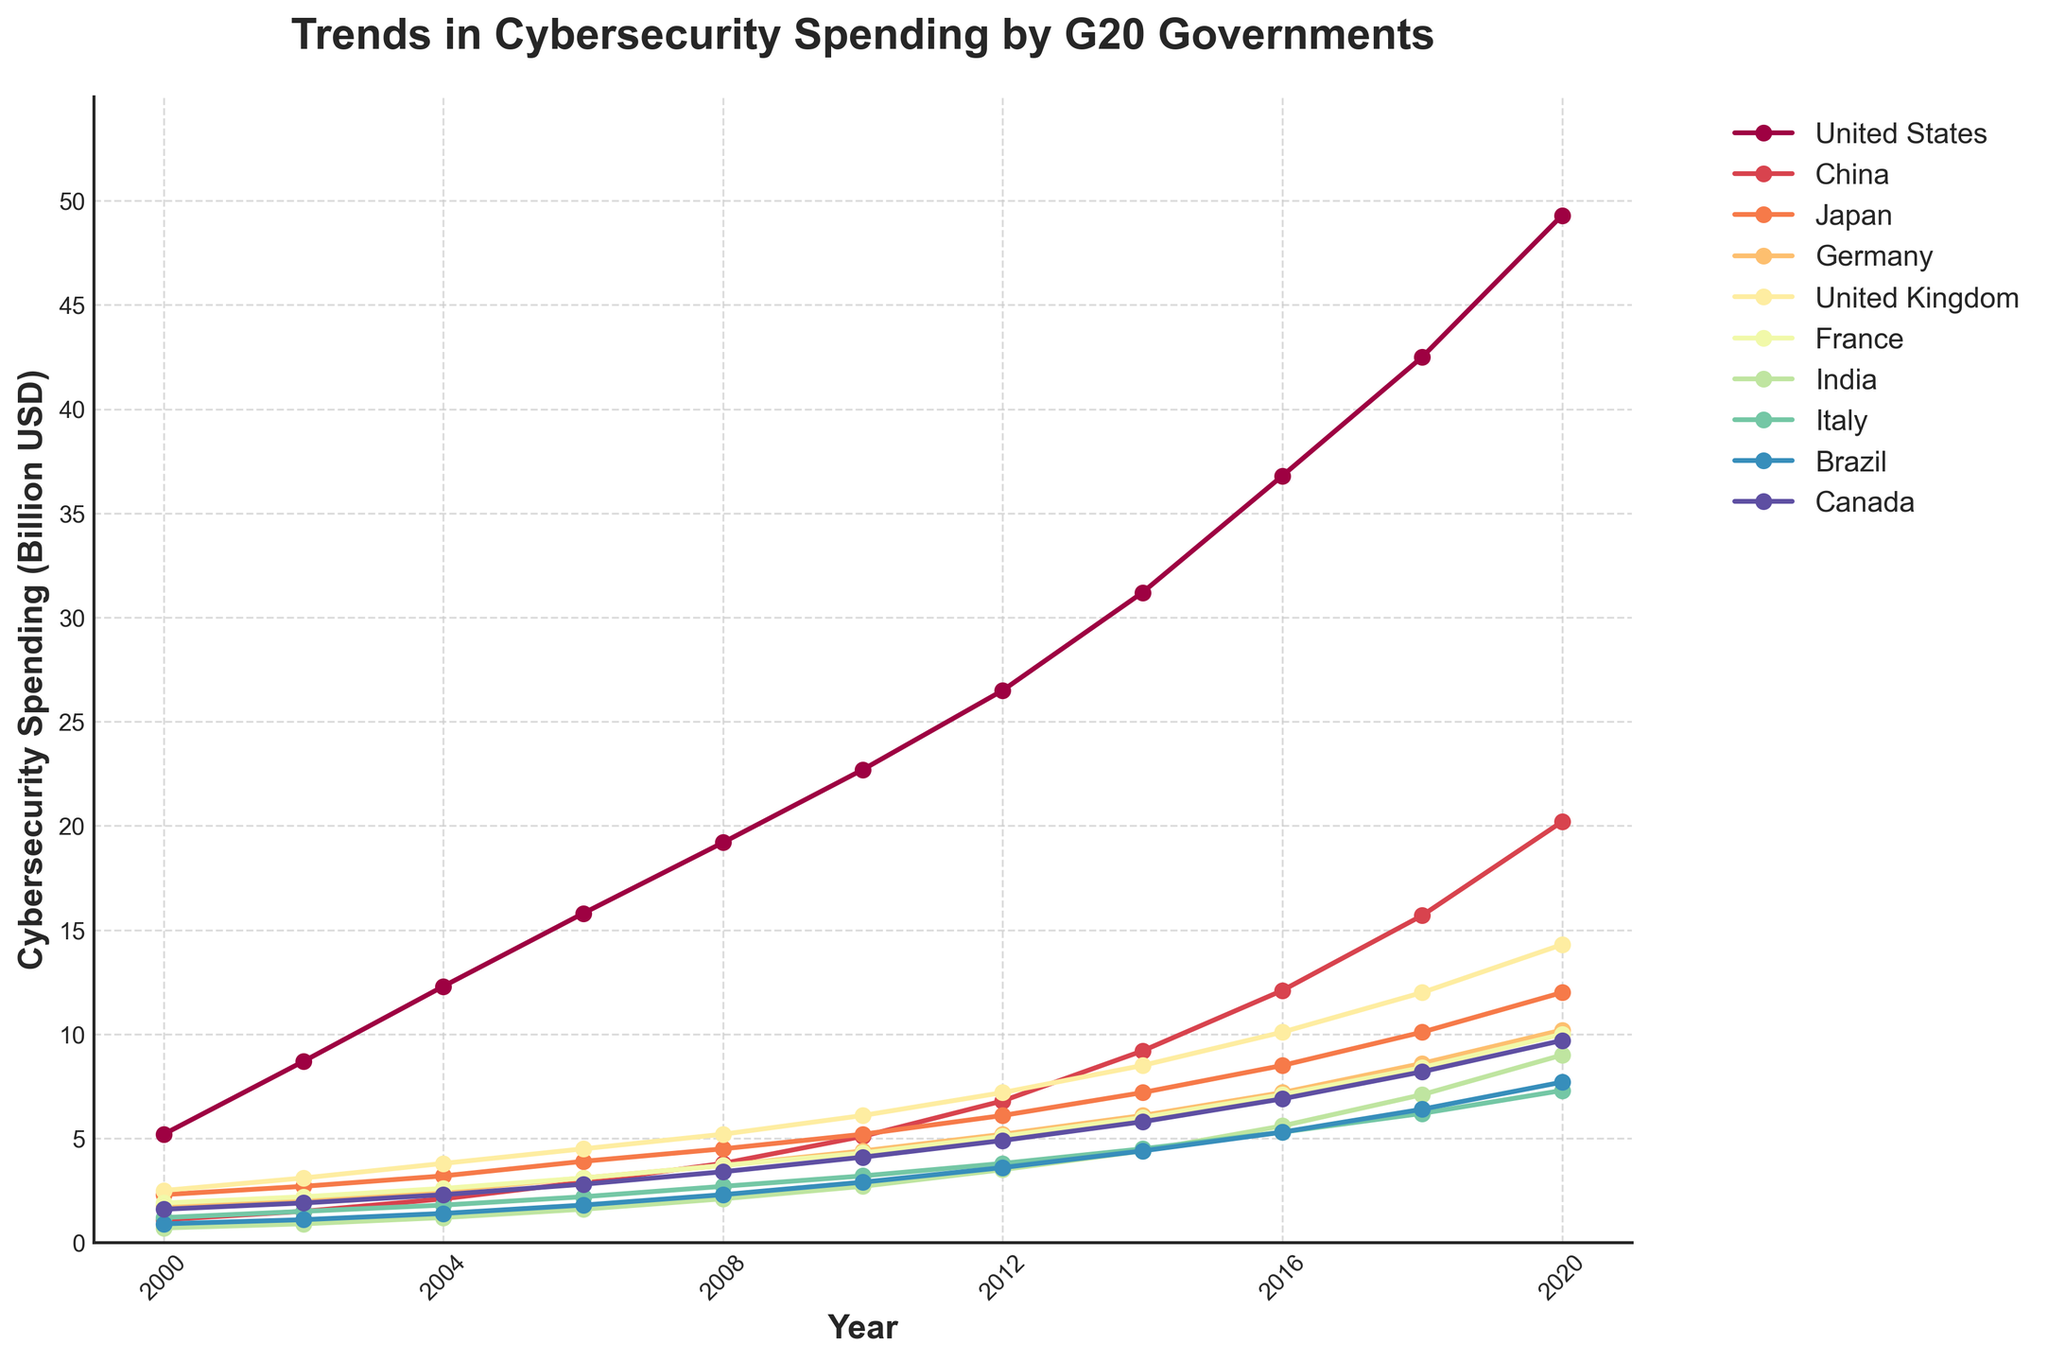Which country had the highest cybersecurity spending in 2020? Look at the highest point on the chart in 2020 to find the country. It shows that the United States had the highest spending in 2020.
Answer: United States What was the difference in cybersecurity spending between China and the United Kingdom in 2008? Identify the spending values for China and the United Kingdom in 2008 and subtract the UK's spending from China's. In 2008, China spent 3.8 billion USD and the UK spent 5.2 billion USD. The difference is 5.2 - 3.8 = 1.4 billion USD.
Answer: 1.4 billion USD Which country showed the most significant increase in cybersecurity spending between 2000 and 2020? Evaluate the increase in spending for each country from 2000 to 2020 by subtracting 2000 values from 2020 values. The United States increased from 5.2 billion USD to 49.3 billion USD, which is the largest increase.
Answer: United States In which year did Germany first spend more than 5 billion USD on cybersecurity? Find the year when Germany's spending first surpasses 5 billion USD. According to the chart, this happened in 2012.
Answer: 2012 How does Japan's cybersecurity spending in 2014 compare to France's in 2018? Look at Japan's spending in 2014 and France's in 2018. Japan spent 7.2 billion USD in 2014, and France spent 8.4 billion USD in 2018. France's spending in 2018 was higher.
Answer: France's spending in 2018 was higher What is the average cybersecurity spending of Canada between 2008 and 2020? Identify the spending amounts for Canada from 2008 to 2020, add them up and divide by the count of years (7 years total between 2010 and 2020, inclusive). (3.4 + 4.1 + 4.9 + 5.8 + 6.9 + 8.2 + 9.7) = 43, so the average is 43 / 7 = 6.14 billion USD.
Answer: 6.14 billion USD Which countries' cybersecurity spending crossed the 10 billion USD mark by 2016? By looking at the year 2016, identify all countries with spending above the 10 billion USD threshold. According to the figure: United States, China, and United Kingdom.
Answer: United States, China, United Kingdom When did India's cybersecurity spending first surpass 5 billion USD? Look for the year in which India's cybersecurity spending exceeded 5 billion USD according to the chart. This happened in 2016.
Answer: 2016 Which country had the smallest cybersecurity spending in 2000 and how much was it? In the year 2000, look for the lowest spending value on the chart and identify the corresponding country. It was India with 0.7 billion USD.
Answer: India, 0.7 billion USD 